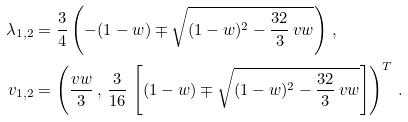<formula> <loc_0><loc_0><loc_500><loc_500>\lambda _ { 1 , 2 } & = \frac { 3 } { 4 } \left ( - ( 1 - w ) \mp \sqrt { ( 1 - w ) ^ { 2 } - \frac { 3 2 } { 3 } \, v w } \right ) \, , \\ v _ { 1 , 2 } & = \left ( \frac { v w } { 3 } \, , \, \frac { 3 } { 1 6 } \, \left [ ( 1 - w ) \mp \sqrt { ( 1 - w ) ^ { 2 } - \frac { 3 2 } { 3 } \, v w } \right ] \right ) ^ { T } \, .</formula> 